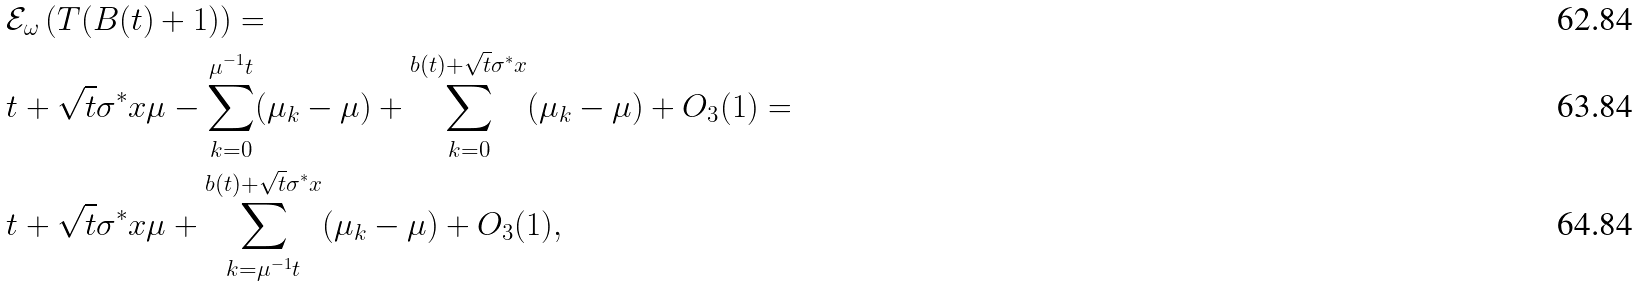Convert formula to latex. <formula><loc_0><loc_0><loc_500><loc_500>& \mathcal { E } _ { \omega } \left ( T ( B ( t ) + 1 ) \right ) = \\ & t + \sqrt { t } \sigma ^ { * } x \mu - \sum _ { k = 0 } ^ { \mu ^ { - 1 } t } ( \mu _ { k } - \mu ) + \sum _ { k = 0 } ^ { b ( t ) + \sqrt { t } \sigma ^ { * } x } ( \mu _ { k } - \mu ) + O _ { 3 } ( 1 ) = \\ & t + \sqrt { t } \sigma ^ { * } x \mu + \sum _ { k = \mu ^ { - 1 } t } ^ { b ( t ) + \sqrt { t } \sigma ^ { * } x } ( \mu _ { k } - \mu ) + O _ { 3 } ( 1 ) ,</formula> 